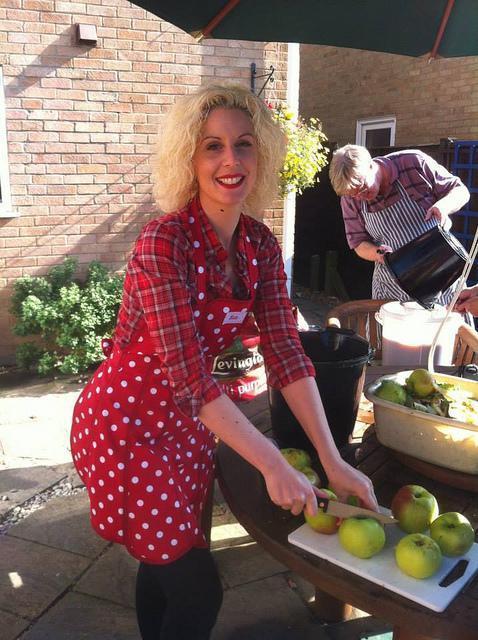How many apples?
Give a very brief answer. 5. How many people are visible?
Give a very brief answer. 2. How many cars are along side the bus?
Give a very brief answer. 0. 